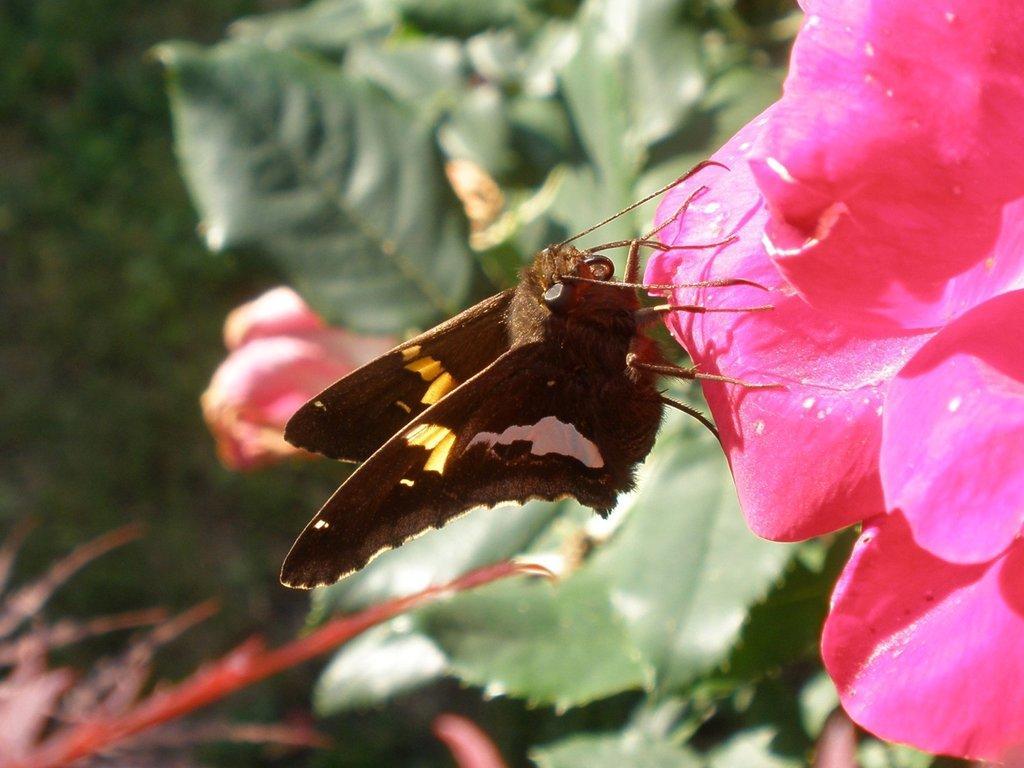In one or two sentences, can you explain what this image depicts? Here I can see a brown color butterfly on a pink color flower which is at the right side. In the background green color leaves are visible. At the left bottom of the image there is a plant. The background is blurred. 